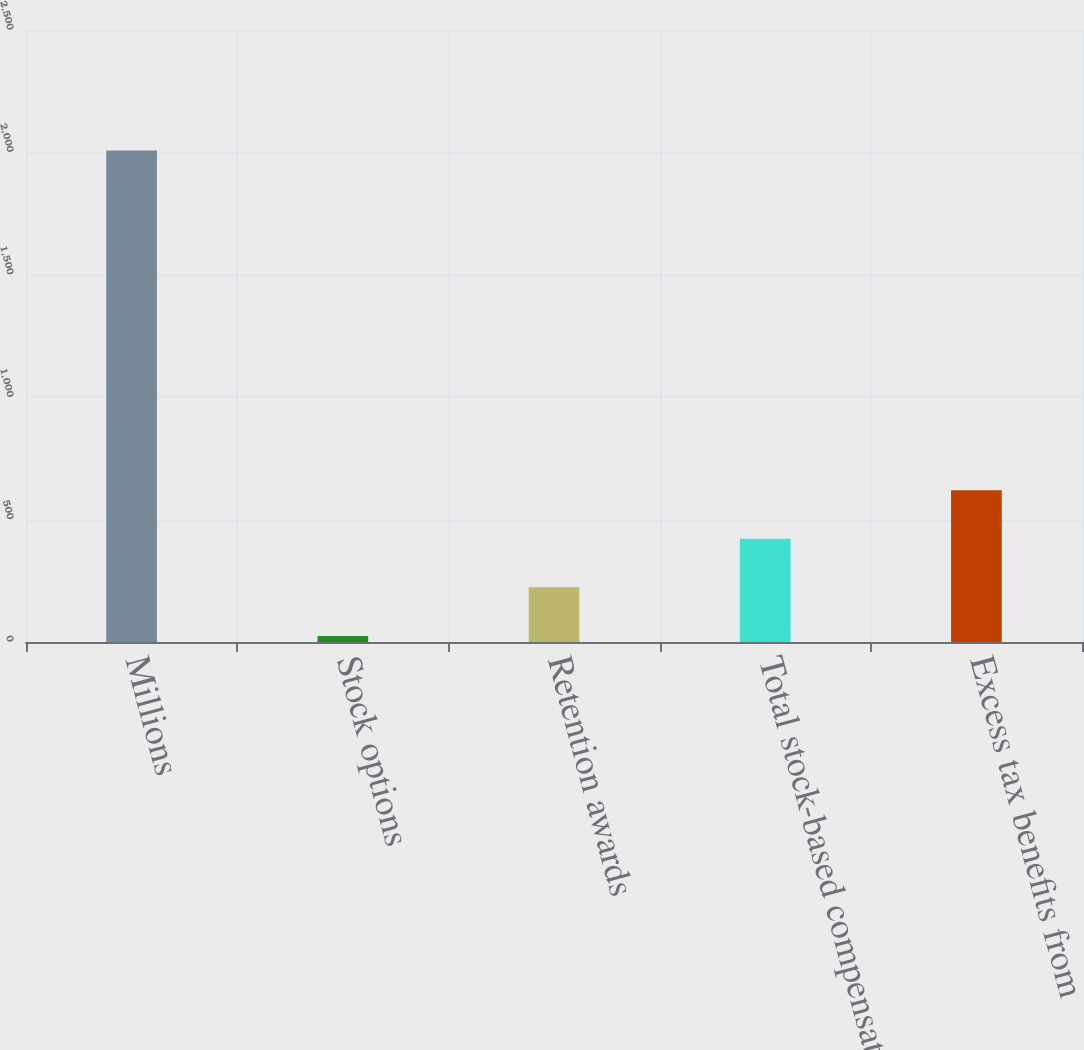Convert chart to OTSL. <chart><loc_0><loc_0><loc_500><loc_500><bar_chart><fcel>Millions<fcel>Stock options<fcel>Retention awards<fcel>Total stock-based compensation<fcel>Excess tax benefits from<nl><fcel>2008<fcel>25<fcel>223.3<fcel>421.6<fcel>619.9<nl></chart> 